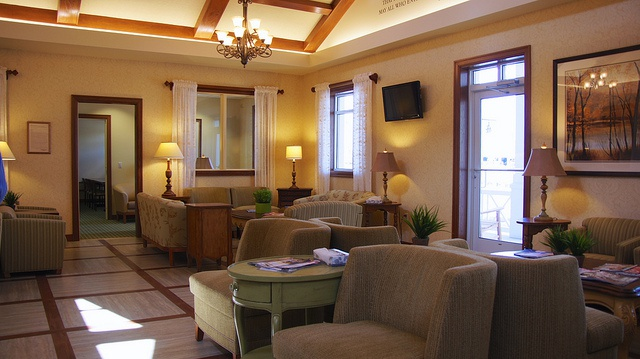Describe the objects in this image and their specific colors. I can see chair in tan, maroon, black, and brown tones, couch in tan, maroon, black, and brown tones, chair in tan, black, gray, and maroon tones, chair in tan, maroon, and black tones, and chair in tan, black, maroon, and brown tones in this image. 